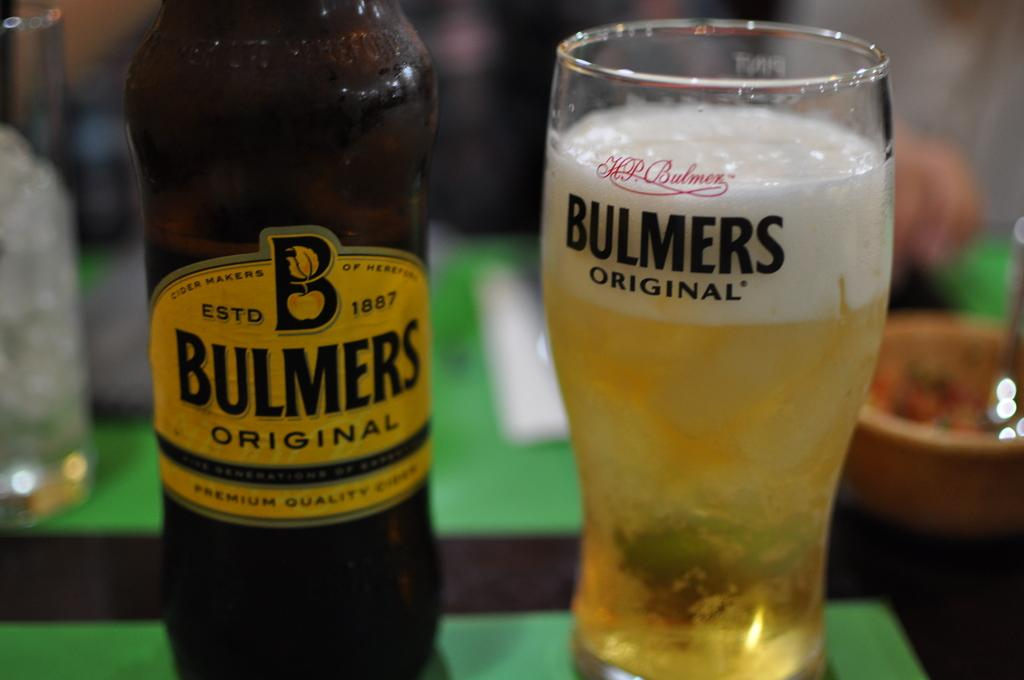<image>
Write a terse but informative summary of the picture. A bottle and glass that both read Bulmers Original. 